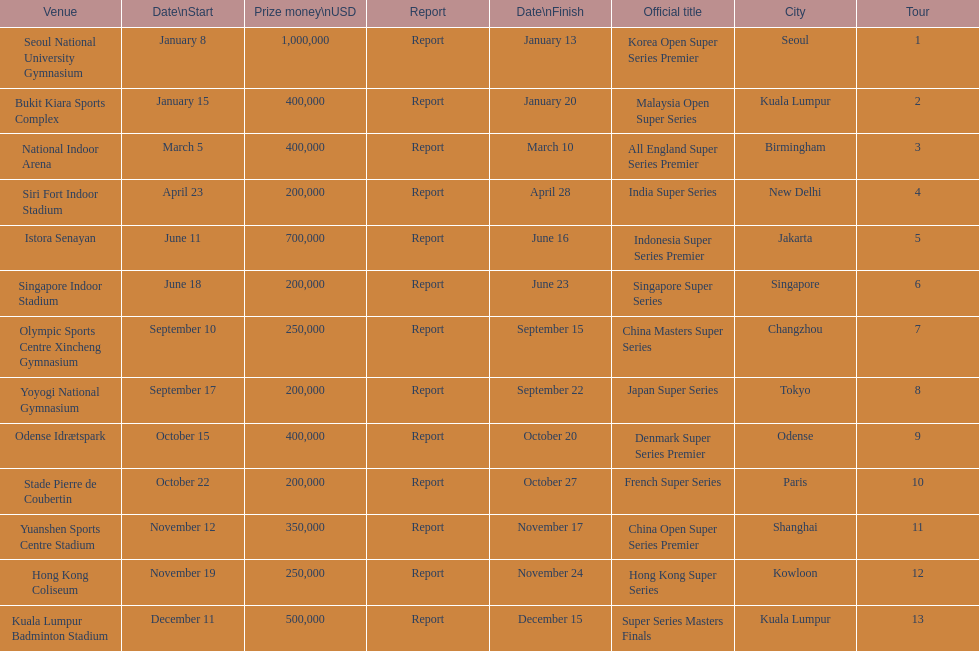How many days does the japan super series last? 5. 